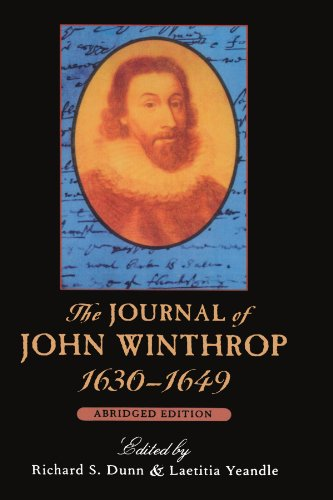What era does John Winthrop's journal cover, and why is it significant? John Winthrop's journal covers the early 17th century, specifically from 1630 to 1649. This period is crucial as it includes the founding of the Massachusetts Bay Colony and early governance in New England, providing insights into colonization and early American society. 